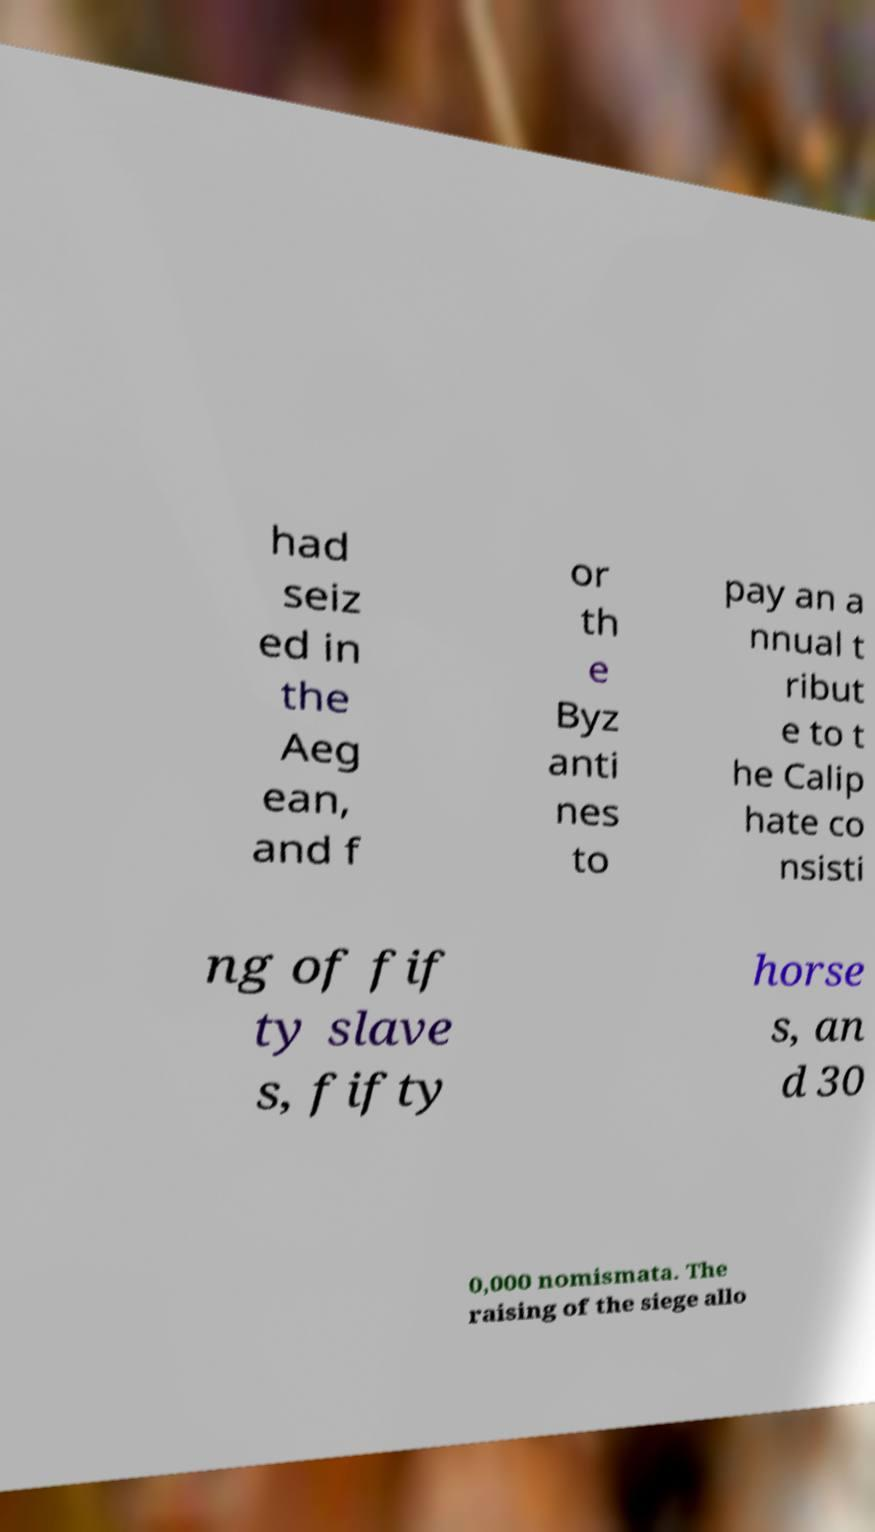Can you read and provide the text displayed in the image?This photo seems to have some interesting text. Can you extract and type it out for me? had seiz ed in the Aeg ean, and f or th e Byz anti nes to pay an a nnual t ribut e to t he Calip hate co nsisti ng of fif ty slave s, fifty horse s, an d 30 0,000 nomismata. The raising of the siege allo 